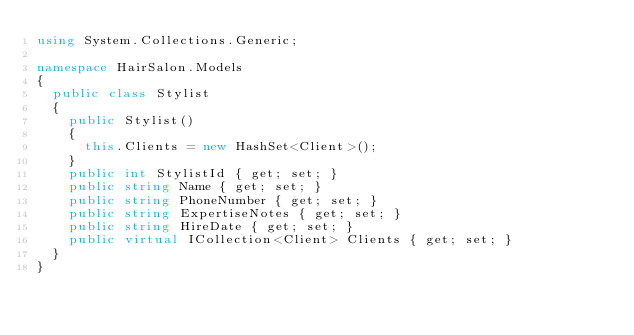<code> <loc_0><loc_0><loc_500><loc_500><_C#_>using System.Collections.Generic;

namespace HairSalon.Models
{
  public class Stylist
  {
    public Stylist()
    {
      this.Clients = new HashSet<Client>();
    }
    public int StylistId { get; set; }
    public string Name { get; set; }
    public string PhoneNumber { get; set; }
    public string ExpertiseNotes { get; set; }
    public string HireDate { get; set; }
    public virtual ICollection<Client> Clients { get; set; }
  }
}</code> 